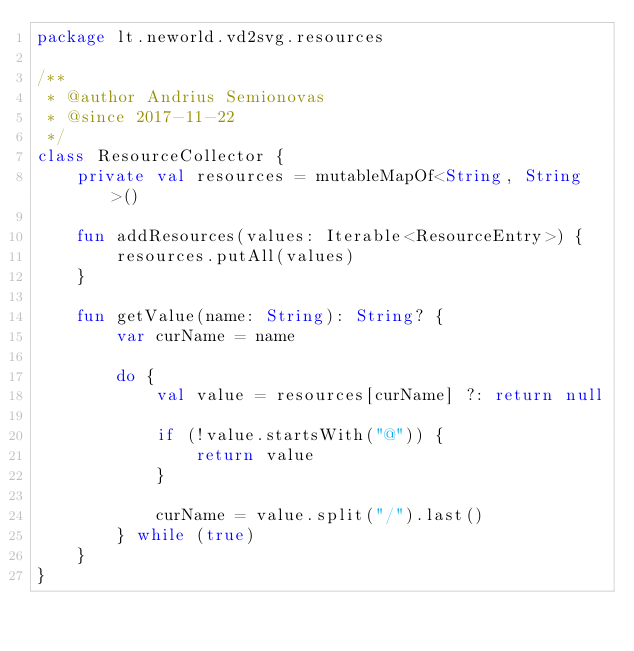<code> <loc_0><loc_0><loc_500><loc_500><_Kotlin_>package lt.neworld.vd2svg.resources

/**
 * @author Andrius Semionovas
 * @since 2017-11-22
 */
class ResourceCollector {
    private val resources = mutableMapOf<String, String>()

    fun addResources(values: Iterable<ResourceEntry>) {
        resources.putAll(values)
    }

    fun getValue(name: String): String? {
        var curName = name

        do {
            val value = resources[curName] ?: return null

            if (!value.startsWith("@")) {
                return value
            }

            curName = value.split("/").last()
        } while (true)
    }
}</code> 